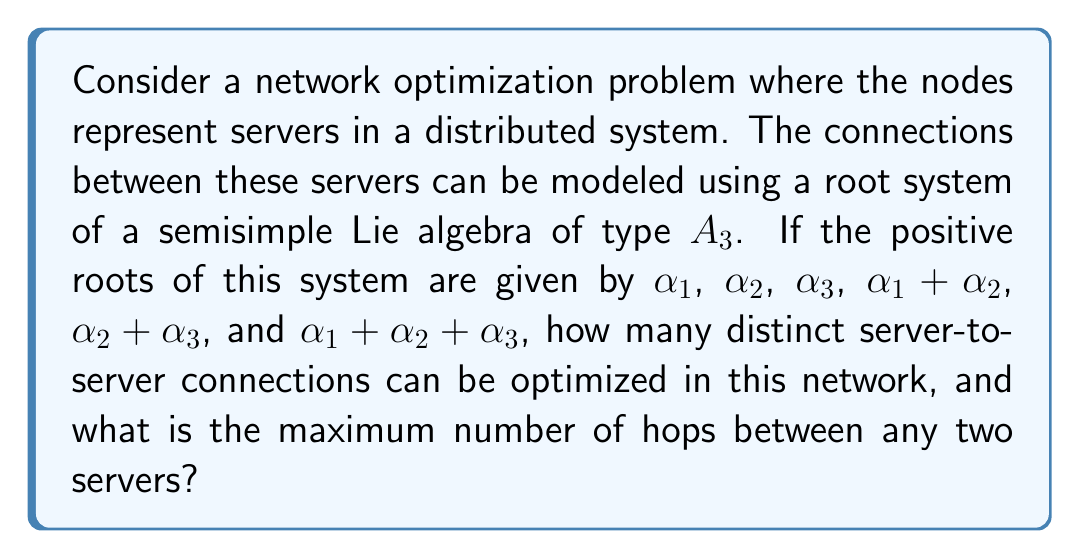Teach me how to tackle this problem. To solve this problem, we need to analyze the root system of the $A_3$ Lie algebra and interpret it in the context of network optimization:

1. The root system of $A_3$ corresponds to the special linear group $SL(4, \mathbb{C})$ or $SU(4)$.

2. The positive roots represent the possible connections between servers:
   $$\{\alpha_1, \alpha_2, \alpha_3, \alpha_1 + \alpha_2, \alpha_2 + \alpha_3, \alpha_1 + \alpha_2 + \alpha_3\}$$

3. Each simple root ($\alpha_1$, $\alpha_2$, $\alpha_3$) represents a direct connection between adjacent servers.

4. Compound roots represent connections that span multiple servers:
   - $\alpha_1 + \alpha_2$ and $\alpha_2 + \alpha_3$ represent 2-hop connections
   - $\alpha_1 + \alpha_2 + \alpha_3$ represents a 3-hop connection

5. To count the distinct server-to-server connections:
   - 3 direct connections (simple roots)
   - 2 two-hop connections
   - 1 three-hop connection
   Total: 3 + 2 + 1 = 6 distinct connections

6. The maximum number of hops is determined by the highest order root, which is $\alpha_1 + \alpha_2 + \alpha_3$, representing 3 hops.

This root system provides a framework for optimizing connections in the network, where each root corresponds to a potential path for data transmission or load balancing between servers.
Answer: The network can have 6 distinct server-to-server connections that can be optimized, and the maximum number of hops between any two servers is 3. 